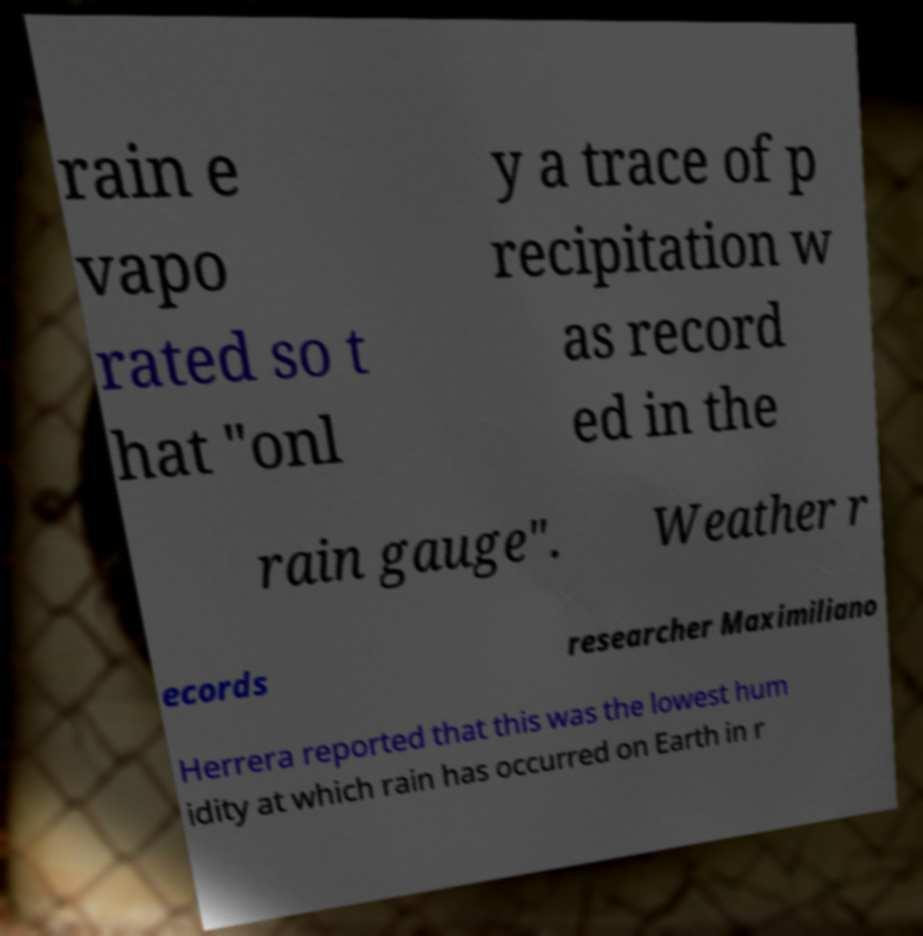Could you assist in decoding the text presented in this image and type it out clearly? rain e vapo rated so t hat "onl y a trace of p recipitation w as record ed in the rain gauge". Weather r ecords researcher Maximiliano Herrera reported that this was the lowest hum idity at which rain has occurred on Earth in r 